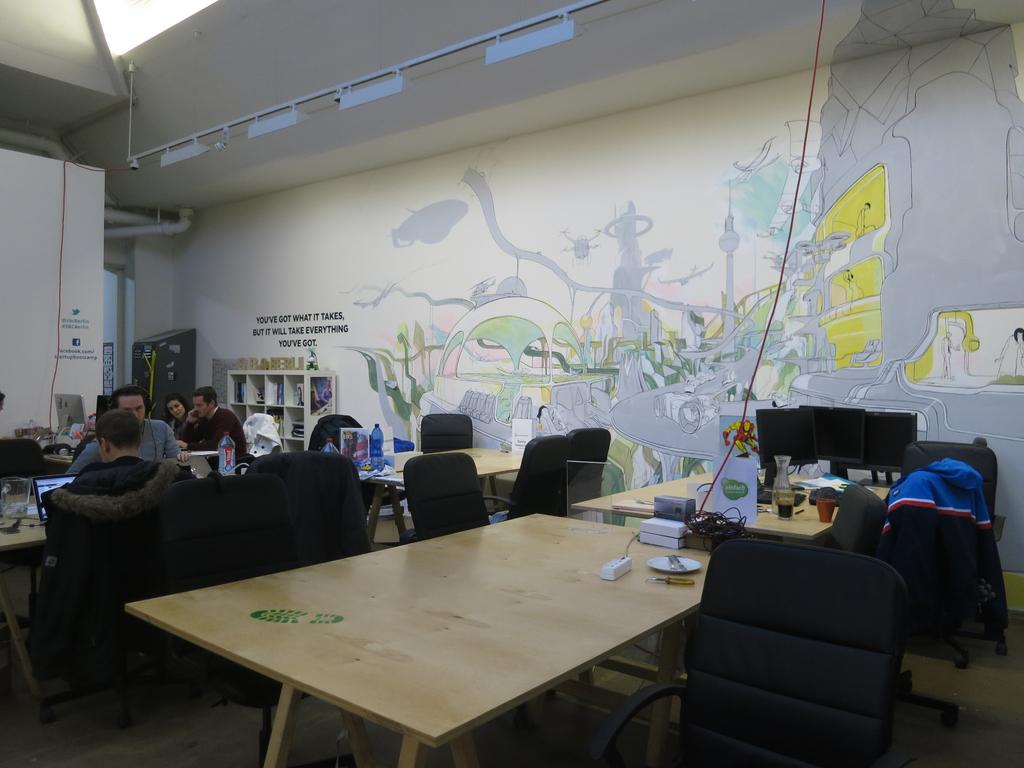What are the people in the image doing? The people in the image are sitting on chairs. How many chairs are visible in the image? There are additional chairs in the image besides the ones the people are sitting on. What type of furniture is also present in the image? There are tables in the image. What can be seen on the tables in the image? There are monitors on at least one table in the image. What type of bucket is being used for the party in the image? There is no bucket or party present in the image; it features people sitting on chairs and tables with monitors. What type of growth is visible on the chairs in the image? There is no growth visible on the chairs in the image; they appear to be standard chairs. 